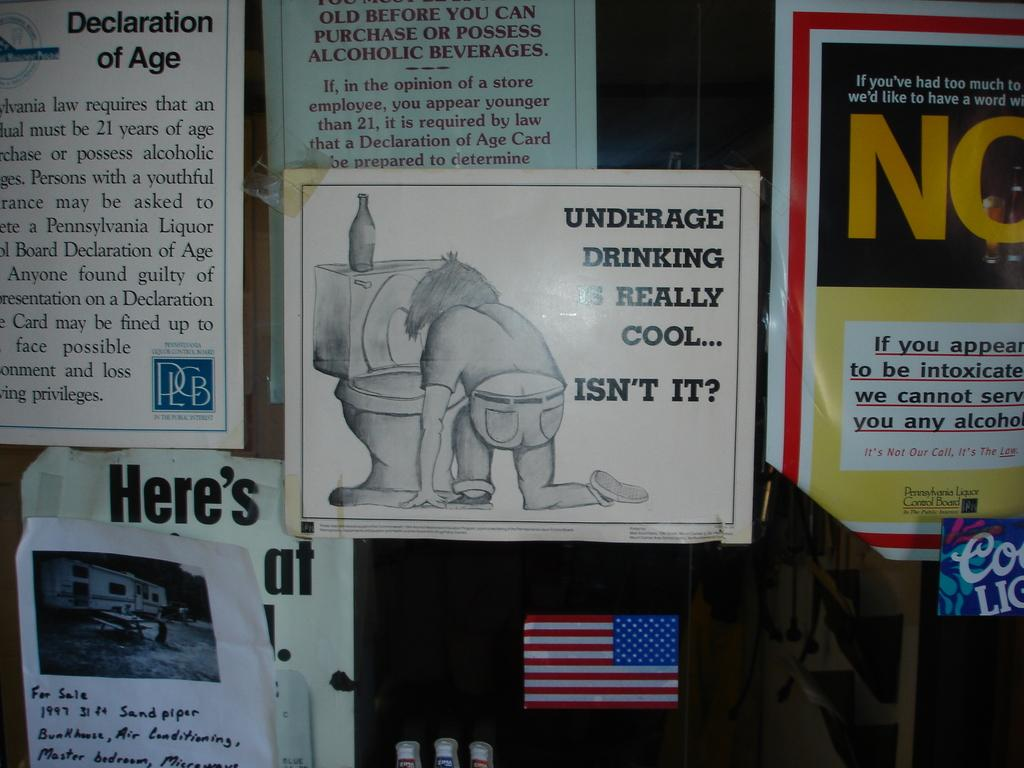<image>
Relay a brief, clear account of the picture shown. a flyer on a wall that says 'underage drinking is really cool... isn't it?' 